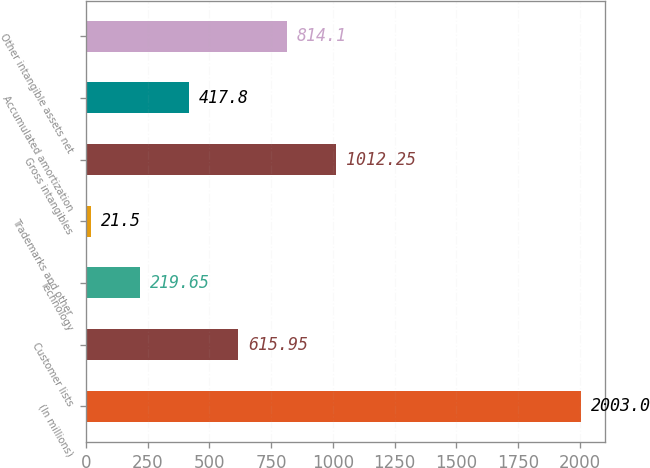Convert chart to OTSL. <chart><loc_0><loc_0><loc_500><loc_500><bar_chart><fcel>(In millions)<fcel>Customer lists<fcel>Technology<fcel>Trademarks and other<fcel>Gross intangibles<fcel>Accumulated amortization<fcel>Other intangible assets net<nl><fcel>2003<fcel>615.95<fcel>219.65<fcel>21.5<fcel>1012.25<fcel>417.8<fcel>814.1<nl></chart> 